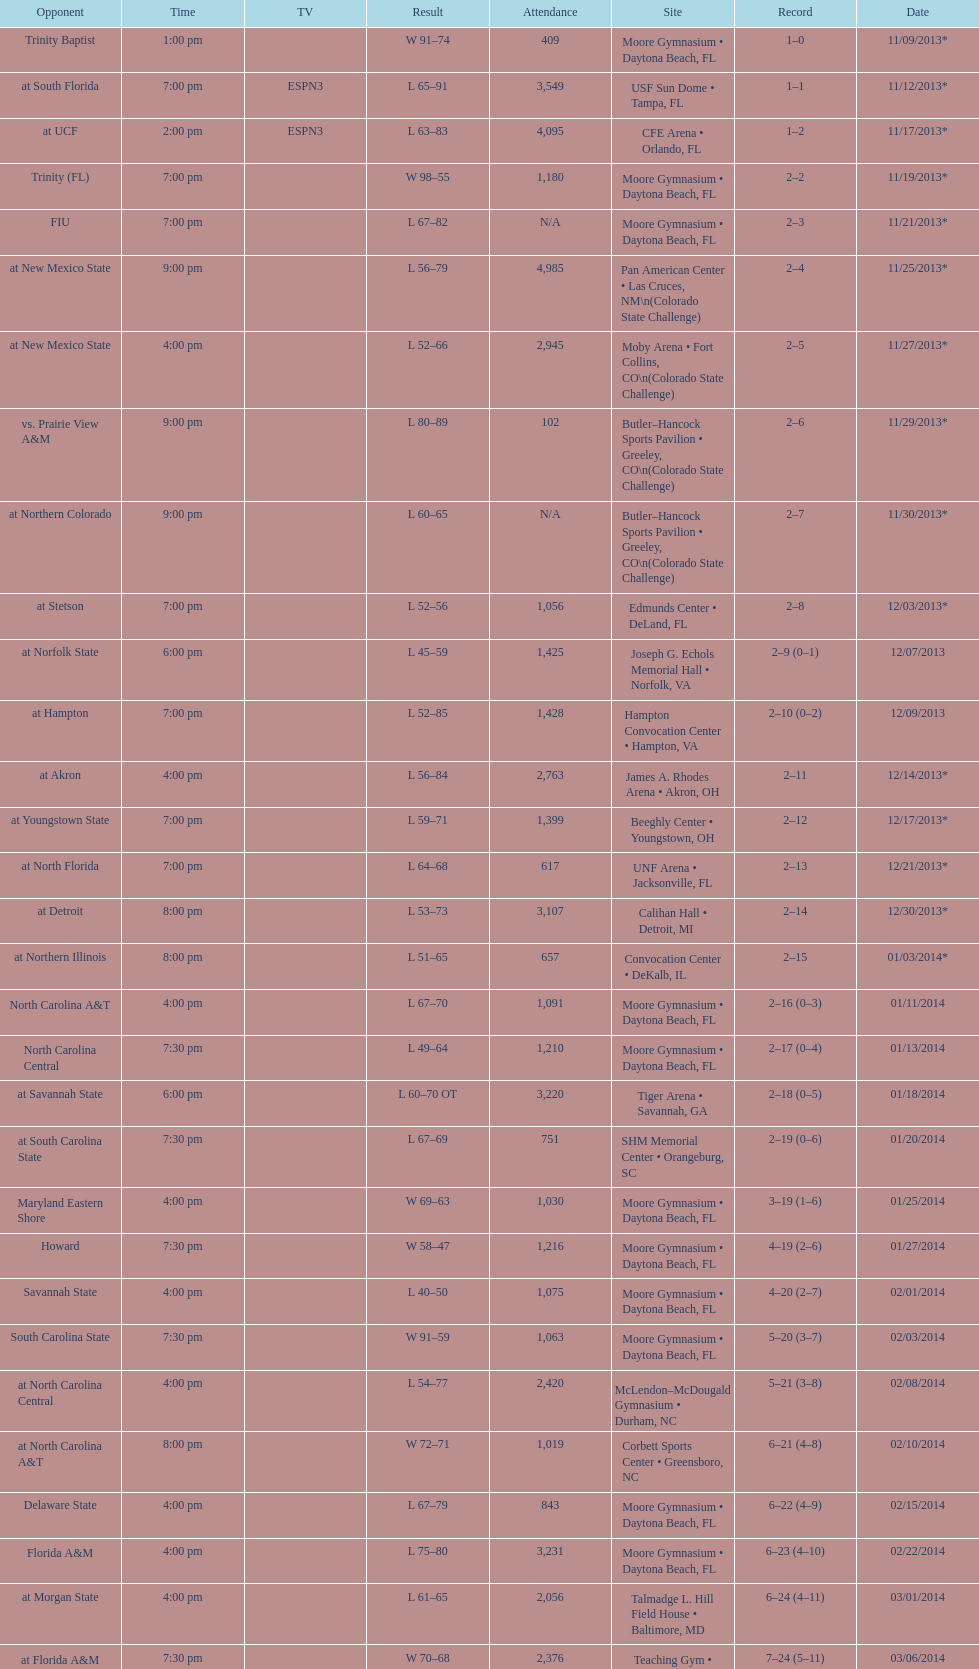How many games did the wildcats play in daytona beach, fl? 11. 